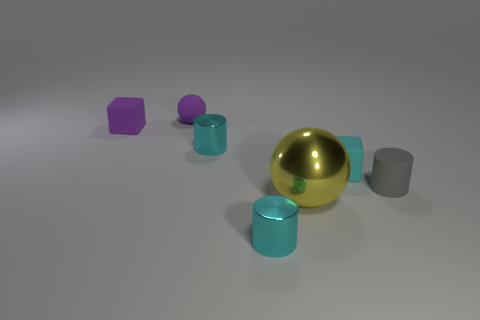What is the overall mood or theme of this image? The image portrays a minimalist setting with geometric shapes, suggesting a tranquil and contemplative mood, possibly representing balance or harmony through the arrangement of objects. 